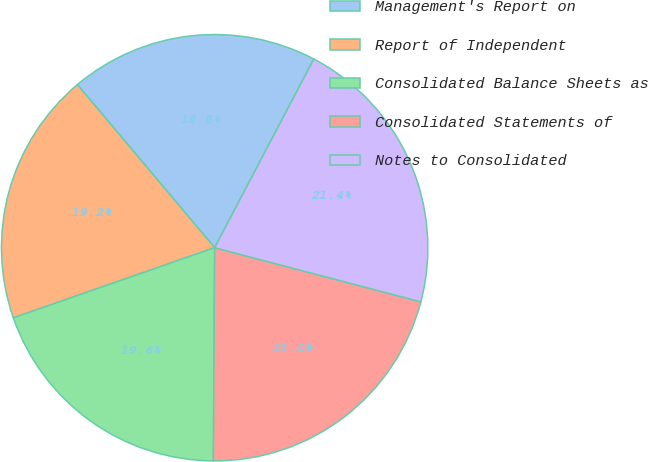Convert chart to OTSL. <chart><loc_0><loc_0><loc_500><loc_500><pie_chart><fcel>Management's Report on<fcel>Report of Independent<fcel>Consolidated Balance Sheets as<fcel>Consolidated Statements of<fcel>Notes to Consolidated<nl><fcel>18.84%<fcel>19.2%<fcel>19.57%<fcel>21.01%<fcel>21.38%<nl></chart> 